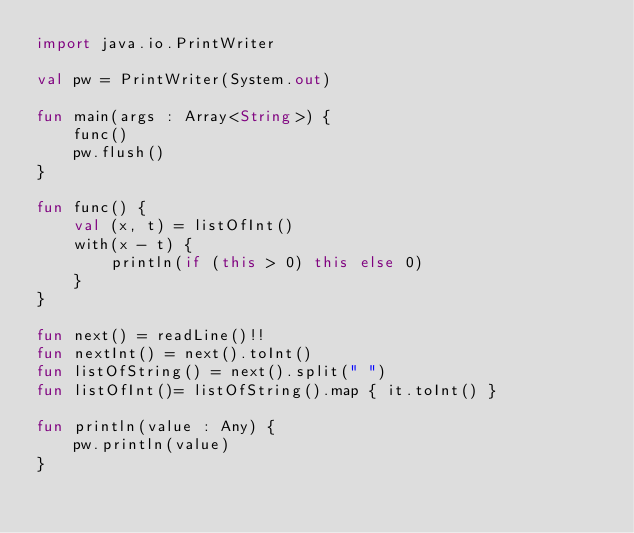Convert code to text. <code><loc_0><loc_0><loc_500><loc_500><_Kotlin_>import java.io.PrintWriter

val pw = PrintWriter(System.out)

fun main(args : Array<String>) {
    func()
    pw.flush()
}

fun func() {
    val (x, t) = listOfInt()
    with(x - t) {
        println(if (this > 0) this else 0)
    }
}

fun next() = readLine()!!
fun nextInt() = next().toInt()
fun listOfString() = next().split(" ")
fun listOfInt()= listOfString().map { it.toInt() }

fun println(value : Any) {
    pw.println(value)
}</code> 